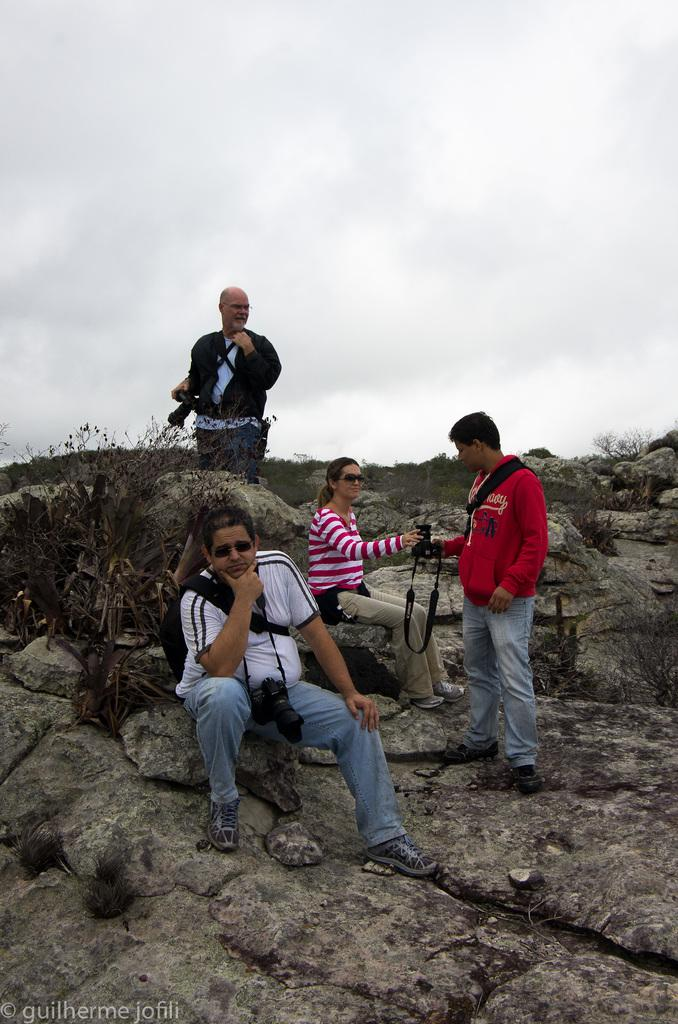What can be seen on the hill in the image? There are persons on the hill in the image. What type of vegetation is on the left side of the image? There are plants on the left side of the image. What is visible at the top of the image? The sky is visible at the top of the image. What type of music can be heard playing in the image? There is no music present in the image, as it is a still photograph. Can you describe the advertisement visible on the hill in the image? There is no advertisement visible on the hill in the image; it features persons and plants. 